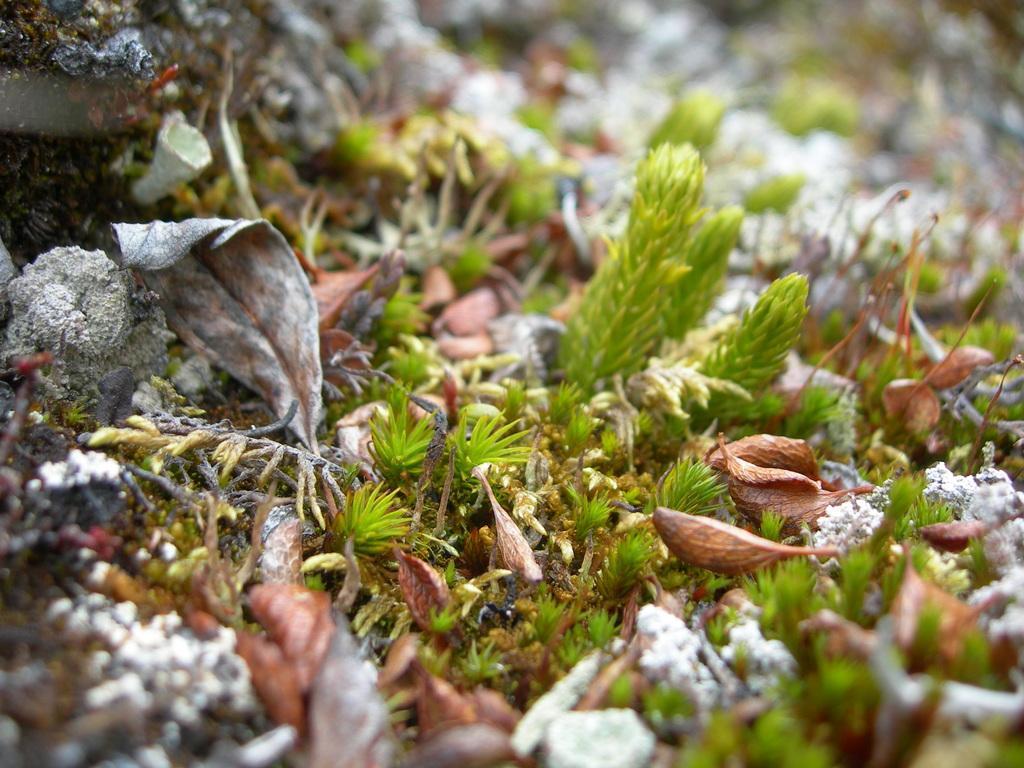Could you give a brief overview of what you see in this image? In this image I can see grass and on it I can see few brown colour things. I can also see this image is little bit blurry. 